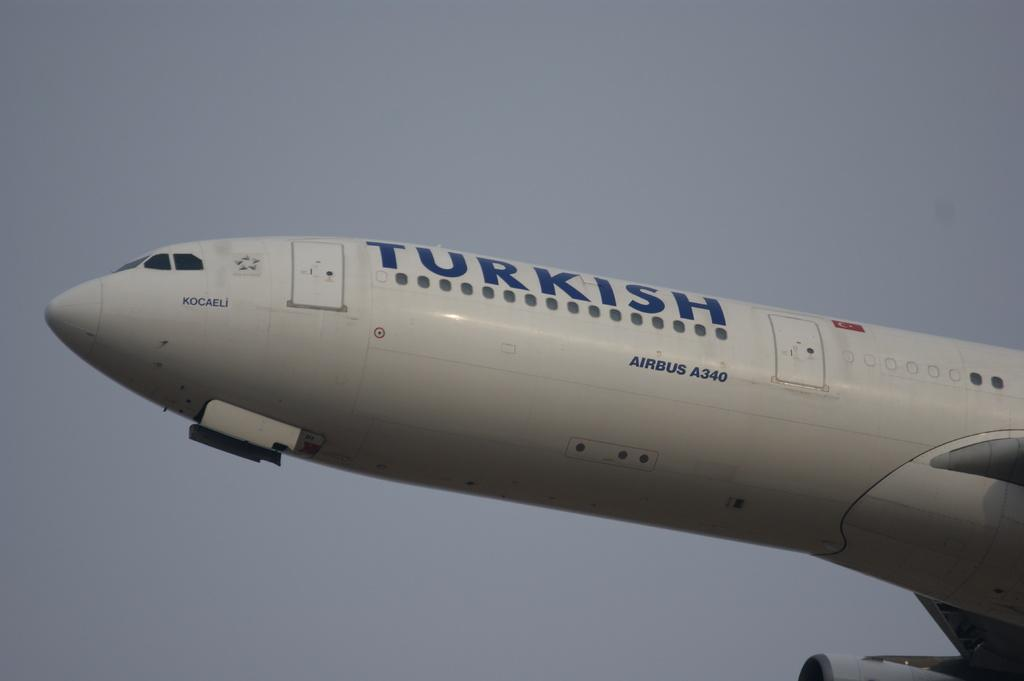<image>
Present a compact description of the photo's key features. White airplane that says Turkish in blue letters. 